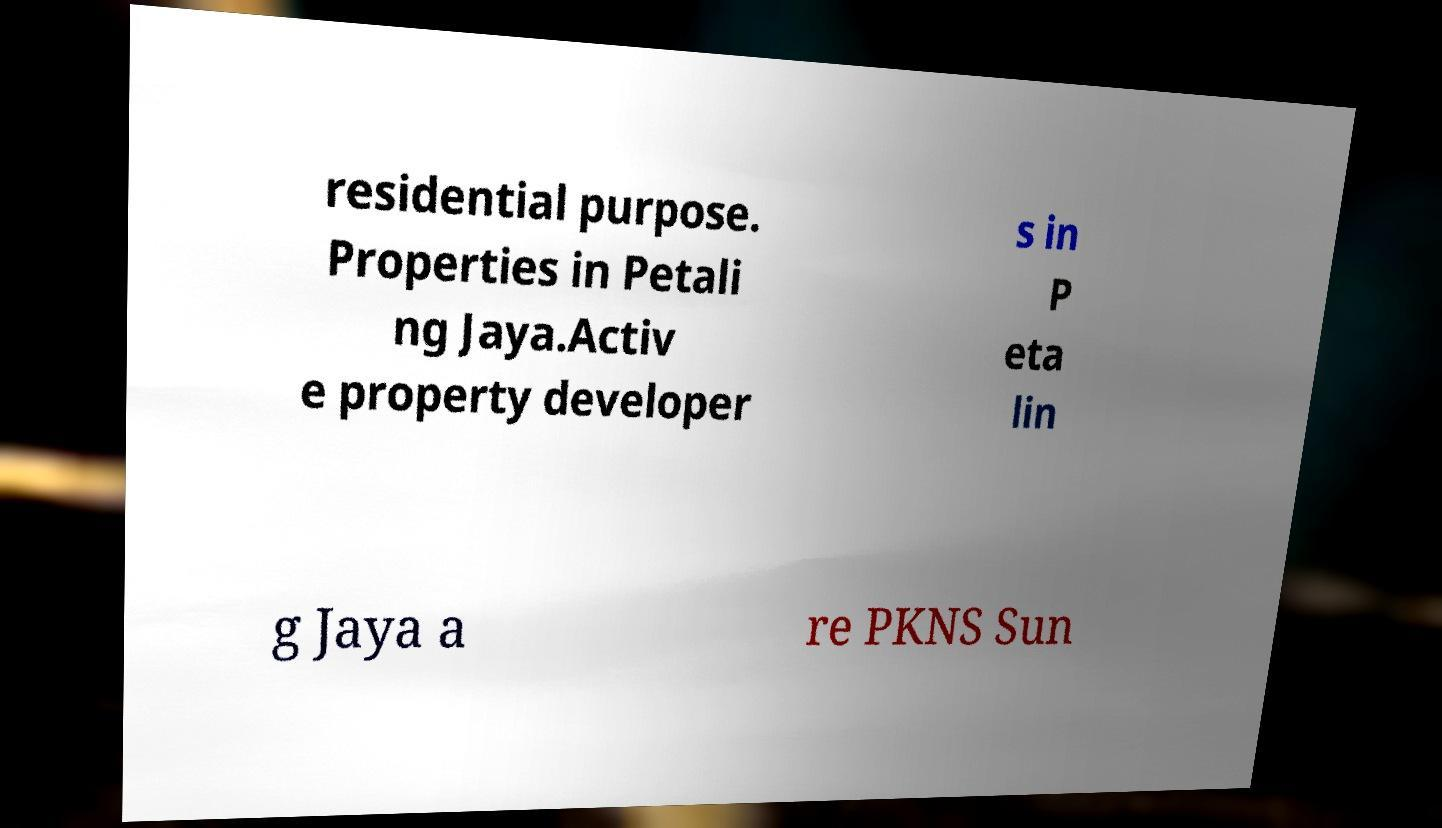Could you extract and type out the text from this image? residential purpose. Properties in Petali ng Jaya.Activ e property developer s in P eta lin g Jaya a re PKNS Sun 